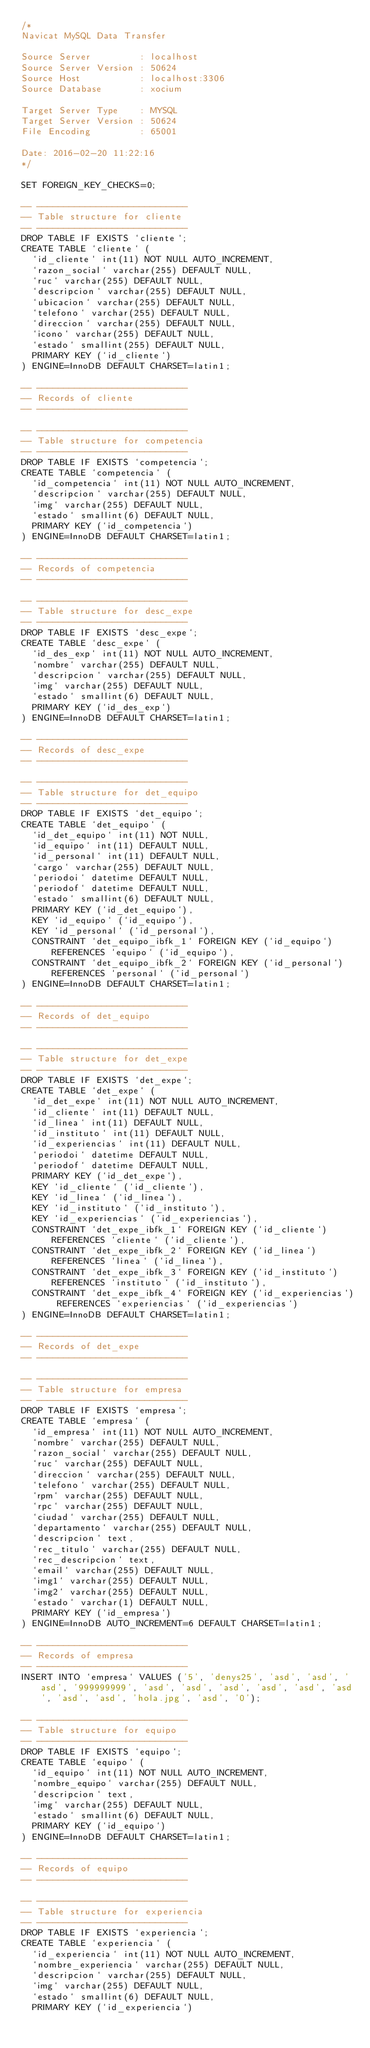<code> <loc_0><loc_0><loc_500><loc_500><_SQL_>/*
Navicat MySQL Data Transfer

Source Server         : localhost
Source Server Version : 50624
Source Host           : localhost:3306
Source Database       : xocium

Target Server Type    : MYSQL
Target Server Version : 50624
File Encoding         : 65001

Date: 2016-02-20 11:22:16
*/

SET FOREIGN_KEY_CHECKS=0;

-- ----------------------------
-- Table structure for cliente
-- ----------------------------
DROP TABLE IF EXISTS `cliente`;
CREATE TABLE `cliente` (
  `id_cliente` int(11) NOT NULL AUTO_INCREMENT,
  `razon_social` varchar(255) DEFAULT NULL,
  `ruc` varchar(255) DEFAULT NULL,
  `descripcion` varchar(255) DEFAULT NULL,
  `ubicacion` varchar(255) DEFAULT NULL,
  `telefono` varchar(255) DEFAULT NULL,
  `direccion` varchar(255) DEFAULT NULL,
  `icono` varchar(255) DEFAULT NULL,
  `estado` smallint(255) DEFAULT NULL,
  PRIMARY KEY (`id_cliente`)
) ENGINE=InnoDB DEFAULT CHARSET=latin1;

-- ----------------------------
-- Records of cliente
-- ----------------------------

-- ----------------------------
-- Table structure for competencia
-- ----------------------------
DROP TABLE IF EXISTS `competencia`;
CREATE TABLE `competencia` (
  `id_competencia` int(11) NOT NULL AUTO_INCREMENT,
  `descripcion` varchar(255) DEFAULT NULL,
  `img` varchar(255) DEFAULT NULL,
  `estado` smallint(6) DEFAULT NULL,
  PRIMARY KEY (`id_competencia`)
) ENGINE=InnoDB DEFAULT CHARSET=latin1;

-- ----------------------------
-- Records of competencia
-- ----------------------------

-- ----------------------------
-- Table structure for desc_expe
-- ----------------------------
DROP TABLE IF EXISTS `desc_expe`;
CREATE TABLE `desc_expe` (
  `id_des_exp` int(11) NOT NULL AUTO_INCREMENT,
  `nombre` varchar(255) DEFAULT NULL,
  `descripcion` varchar(255) DEFAULT NULL,
  `img` varchar(255) DEFAULT NULL,
  `estado` smallint(6) DEFAULT NULL,
  PRIMARY KEY (`id_des_exp`)
) ENGINE=InnoDB DEFAULT CHARSET=latin1;

-- ----------------------------
-- Records of desc_expe
-- ----------------------------

-- ----------------------------
-- Table structure for det_equipo
-- ----------------------------
DROP TABLE IF EXISTS `det_equipo`;
CREATE TABLE `det_equipo` (
  `id_det_equipo` int(11) NOT NULL,
  `id_equipo` int(11) DEFAULT NULL,
  `id_personal` int(11) DEFAULT NULL,
  `cargo` varchar(255) DEFAULT NULL,
  `periodoi` datetime DEFAULT NULL,
  `periodof` datetime DEFAULT NULL,
  `estado` smallint(6) DEFAULT NULL,
  PRIMARY KEY (`id_det_equipo`),
  KEY `id_equipo` (`id_equipo`),
  KEY `id_personal` (`id_personal`),
  CONSTRAINT `det_equipo_ibfk_1` FOREIGN KEY (`id_equipo`) REFERENCES `equipo` (`id_equipo`),
  CONSTRAINT `det_equipo_ibfk_2` FOREIGN KEY (`id_personal`) REFERENCES `personal` (`id_personal`)
) ENGINE=InnoDB DEFAULT CHARSET=latin1;

-- ----------------------------
-- Records of det_equipo
-- ----------------------------

-- ----------------------------
-- Table structure for det_expe
-- ----------------------------
DROP TABLE IF EXISTS `det_expe`;
CREATE TABLE `det_expe` (
  `id_det_expe` int(11) NOT NULL AUTO_INCREMENT,
  `id_cliente` int(11) DEFAULT NULL,
  `id_linea` int(11) DEFAULT NULL,
  `id_instituto` int(11) DEFAULT NULL,
  `id_experiencias` int(11) DEFAULT NULL,
  `periodoi` datetime DEFAULT NULL,
  `periodof` datetime DEFAULT NULL,
  PRIMARY KEY (`id_det_expe`),
  KEY `id_cliente` (`id_cliente`),
  KEY `id_linea` (`id_linea`),
  KEY `id_instituto` (`id_instituto`),
  KEY `id_experiencias` (`id_experiencias`),
  CONSTRAINT `det_expe_ibfk_1` FOREIGN KEY (`id_cliente`) REFERENCES `cliente` (`id_cliente`),
  CONSTRAINT `det_expe_ibfk_2` FOREIGN KEY (`id_linea`) REFERENCES `linea` (`id_linea`),
  CONSTRAINT `det_expe_ibfk_3` FOREIGN KEY (`id_instituto`) REFERENCES `instituto` (`id_instituto`),
  CONSTRAINT `det_expe_ibfk_4` FOREIGN KEY (`id_experiencias`) REFERENCES `experiencias` (`id_experiencias`)
) ENGINE=InnoDB DEFAULT CHARSET=latin1;

-- ----------------------------
-- Records of det_expe
-- ----------------------------

-- ----------------------------
-- Table structure for empresa
-- ----------------------------
DROP TABLE IF EXISTS `empresa`;
CREATE TABLE `empresa` (
  `id_empresa` int(11) NOT NULL AUTO_INCREMENT,
  `nombre` varchar(255) DEFAULT NULL,
  `razon_social` varchar(255) DEFAULT NULL,
  `ruc` varchar(255) DEFAULT NULL,
  `direccion` varchar(255) DEFAULT NULL,
  `telefono` varchar(255) DEFAULT NULL,
  `rpm` varchar(255) DEFAULT NULL,
  `rpc` varchar(255) DEFAULT NULL,
  `ciudad` varchar(255) DEFAULT NULL,
  `departamento` varchar(255) DEFAULT NULL,
  `descripcion` text,
  `rec_titulo` varchar(255) DEFAULT NULL,
  `rec_descripcion` text,
  `email` varchar(255) DEFAULT NULL,
  `img1` varchar(255) DEFAULT NULL,
  `img2` varchar(255) DEFAULT NULL,
  `estado` varchar(1) DEFAULT NULL,
  PRIMARY KEY (`id_empresa`)
) ENGINE=InnoDB AUTO_INCREMENT=6 DEFAULT CHARSET=latin1;

-- ----------------------------
-- Records of empresa
-- ----------------------------
INSERT INTO `empresa` VALUES ('5', 'denys25', 'asd', 'asd', 'asd', '999999999', 'asd', 'asd', 'asd', 'asd', 'asd', 'asd', 'asd', 'asd', 'hola.jpg', 'asd', '0');

-- ----------------------------
-- Table structure for equipo
-- ----------------------------
DROP TABLE IF EXISTS `equipo`;
CREATE TABLE `equipo` (
  `id_equipo` int(11) NOT NULL AUTO_INCREMENT,
  `nombre_equipo` varchar(255) DEFAULT NULL,
  `descripcion` text,
  `img` varchar(255) DEFAULT NULL,
  `estado` smallint(6) DEFAULT NULL,
  PRIMARY KEY (`id_equipo`)
) ENGINE=InnoDB DEFAULT CHARSET=latin1;

-- ----------------------------
-- Records of equipo
-- ----------------------------

-- ----------------------------
-- Table structure for experiencia
-- ----------------------------
DROP TABLE IF EXISTS `experiencia`;
CREATE TABLE `experiencia` (
  `id_experiencia` int(11) NOT NULL AUTO_INCREMENT,
  `nombre_experiencia` varchar(255) DEFAULT NULL,
  `descripcion` varchar(255) DEFAULT NULL,
  `img` varchar(255) DEFAULT NULL,
  `estado` smallint(6) DEFAULT NULL,
  PRIMARY KEY (`id_experiencia`)</code> 